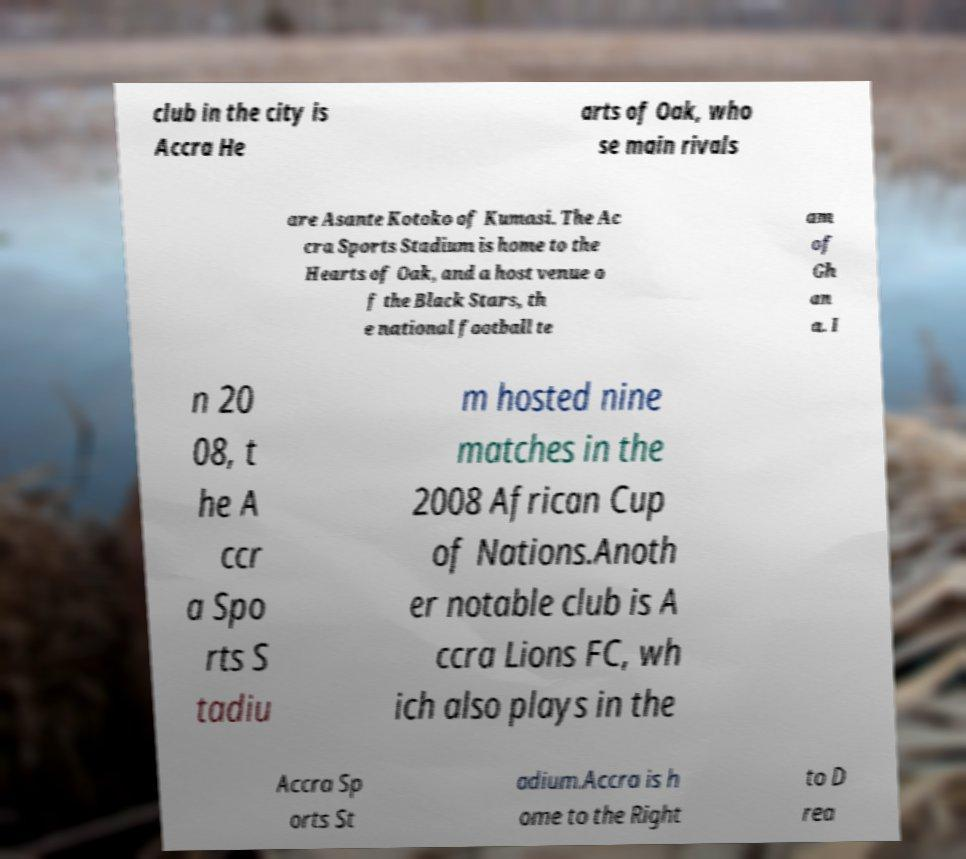Can you read and provide the text displayed in the image?This photo seems to have some interesting text. Can you extract and type it out for me? club in the city is Accra He arts of Oak, who se main rivals are Asante Kotoko of Kumasi. The Ac cra Sports Stadium is home to the Hearts of Oak, and a host venue o f the Black Stars, th e national football te am of Gh an a. I n 20 08, t he A ccr a Spo rts S tadiu m hosted nine matches in the 2008 African Cup of Nations.Anoth er notable club is A ccra Lions FC, wh ich also plays in the Accra Sp orts St adium.Accra is h ome to the Right to D rea 